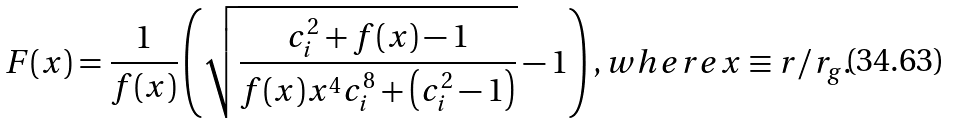Convert formula to latex. <formula><loc_0><loc_0><loc_500><loc_500>F ( x ) = \frac { 1 } { f ( x ) } \left ( \sqrt { \frac { c _ { i } ^ { 2 } + f ( x ) - 1 } { f ( x ) x ^ { 4 } c _ { i } ^ { 8 } + \left ( c _ { i } ^ { 2 } - 1 \right ) } } - 1 \right ) , w h e r e x \equiv r / r _ { g } .</formula> 